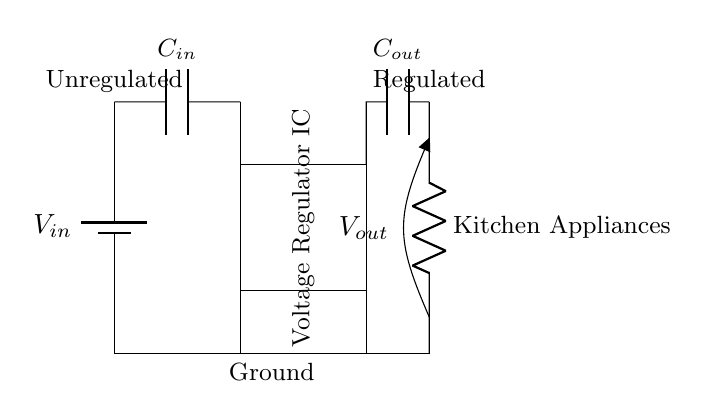What is the input voltage labeled in the circuit? The circuit labels the input voltage as V_in, which is depicted as coming from the battery component.
Answer: V_in What is the purpose of the capacitor labeled C_out? C_out functions as the output capacitor, which helps stabilize the output voltage and filter out any noise. It's connected to the regulated output V_out.
Answer: Stabilizing output What type of load does the circuit supply power to? The circuit supplies power to kitchen appliances, as indicated by the resistor labeled "Kitchen Appliances" connected at the output.
Answer: Kitchen Appliances What is the role of the voltage regulator IC? The voltage regulator IC regulates the input voltage to provide a stable output voltage, ensuring the appliances receive consistent power.
Answer: Regulate voltage How many capacitors are present in the circuit? There are two capacitors present: C_in and C_out, which are responsible for input and output stabilization, respectively.
Answer: Two capacitors What would happen if C_in is removed from the circuit? Removing C_in would likely result in unstable input voltage, leading to fluctuations at the output which could damage the connected appliances.
Answer: Unstable output What is the connection type of the voltage regulator IC to the ground? The voltage regulator IC is directly connected to the ground through a vertical line shown in the circuit, indicating a common ground reference.
Answer: Directly connected 